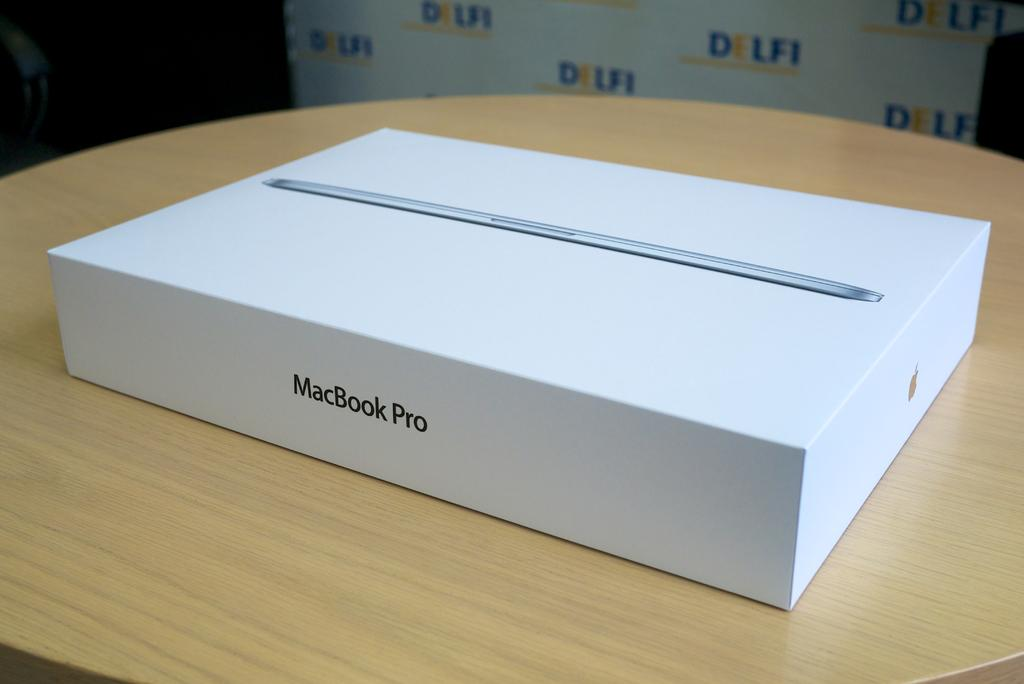<image>
Write a terse but informative summary of the picture. A white MacBook Pro box sitting on a wooden table. 